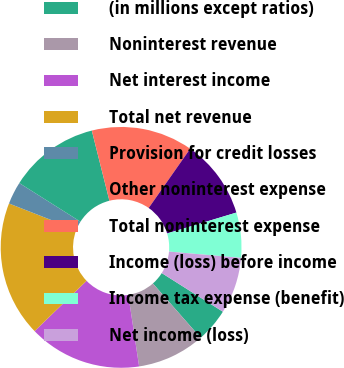<chart> <loc_0><loc_0><loc_500><loc_500><pie_chart><fcel>(in millions except ratios)<fcel>Noninterest revenue<fcel>Net interest income<fcel>Total net revenue<fcel>Provision for credit losses<fcel>Other noninterest expense<fcel>Total noninterest expense<fcel>Income (loss) before income<fcel>Income tax expense (benefit)<fcel>Net income (loss)<nl><fcel>4.55%<fcel>9.09%<fcel>15.15%<fcel>18.18%<fcel>3.03%<fcel>12.12%<fcel>13.64%<fcel>10.61%<fcel>6.06%<fcel>7.58%<nl></chart> 